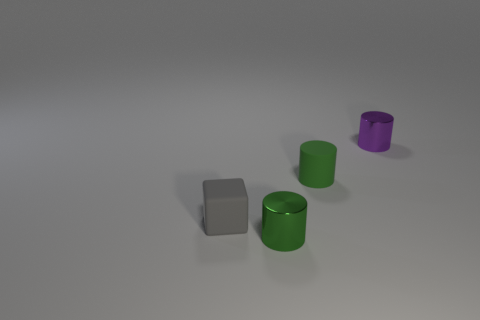There is another tiny green thing that is the same shape as the green shiny object; what material is it?
Keep it short and to the point. Rubber. There is a object that is on the right side of the tiny gray block and in front of the green rubber cylinder; what is its size?
Offer a terse response. Small. There is a green cylinder behind the block; what is its material?
Provide a short and direct response. Rubber. Are there any other things that have the same shape as the small purple thing?
Your response must be concise. Yes. What number of small green matte objects are the same shape as the purple metallic thing?
Offer a terse response. 1. Is the size of the metallic cylinder that is in front of the purple cylinder the same as the gray cube in front of the tiny purple shiny cylinder?
Offer a terse response. Yes. There is a small metal thing that is to the right of the object in front of the gray matte thing; what shape is it?
Provide a succinct answer. Cylinder. Are there an equal number of gray cubes behind the small matte cube and small cylinders?
Offer a very short reply. No. There is a object that is in front of the tiny cube in front of the small green thing behind the block; what is its material?
Your answer should be very brief. Metal. Are there any blue spheres of the same size as the matte cylinder?
Provide a short and direct response. No. 